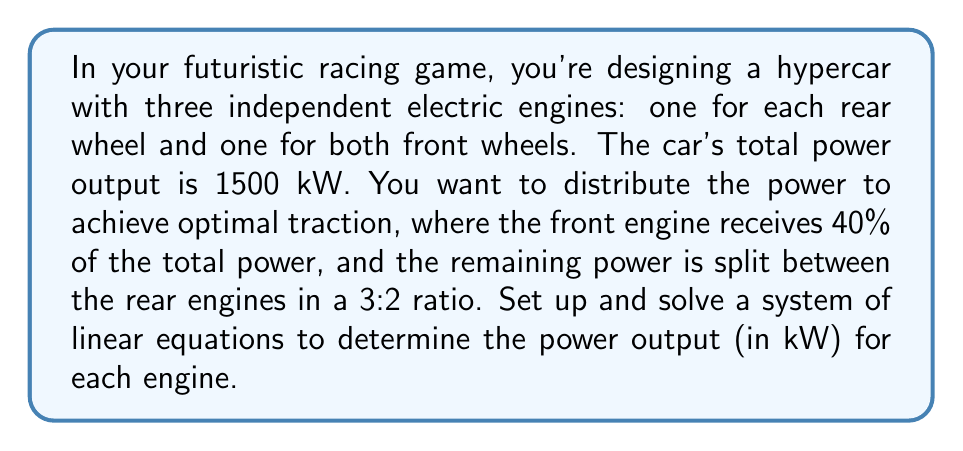What is the answer to this math problem? Let's approach this problem step-by-step using a system of linear equations:

1) Define variables:
   Let $x$ = power output of the front engine
   Let $y$ = power output of the left rear engine
   Let $z$ = power output of the right rear engine

2) Set up the equations:
   Equation 1: Total power
   $$x + y + z = 1500$$

   Equation 2: Front engine power (40% of total)
   $$x = 0.4(1500) = 600$$

   Equation 3: Ratio between rear engines (3:2)
   $$y = \frac{3}{2}z$$

3) Substitute known values:
   $$600 + y + z = 1500$$
   $$y = \frac{3}{2}z$$

4) Simplify:
   $$y + z = 900$$
   $$y = \frac{3}{2}z$$

5) Substitute the second equation into the first:
   $$\frac{3}{2}z + z = 900$$
   $$\frac{5}{2}z = 900$$

6) Solve for $z$:
   $$z = \frac{900}{\frac{5}{2}} = 360$$

7) Solve for $y$:
   $$y = \frac{3}{2}(360) = 540$$

8) Verify $x$:
   $$x = 600$$

Therefore, the power distribution is:
Front engine: 600 kW
Left rear engine: 540 kW
Right rear engine: 360 kW
Answer: Front engine: 600 kW
Left rear engine: 540 kW
Right rear engine: 360 kW 